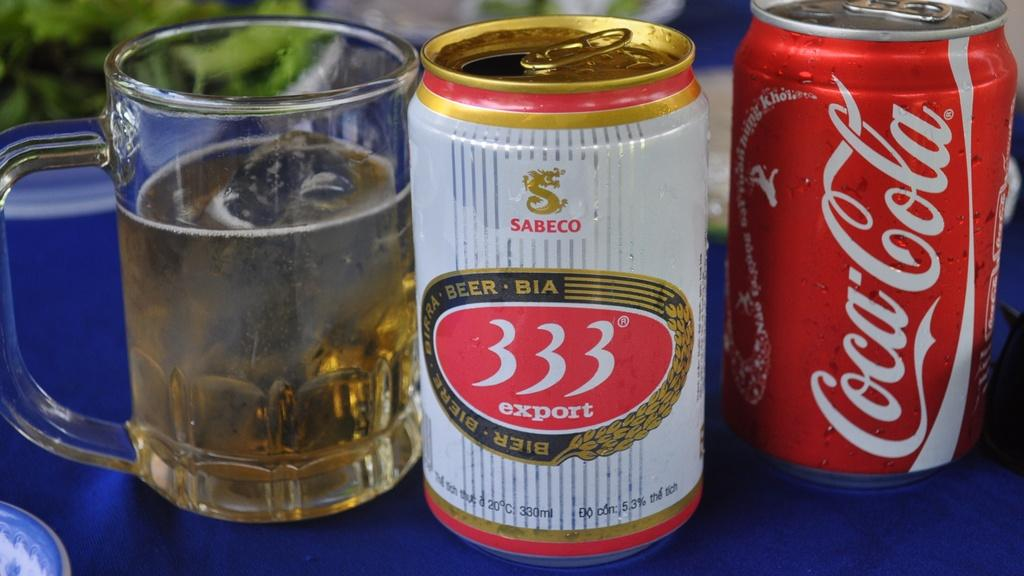Provide a one-sentence caption for the provided image. the numbers 333 are on the can of soda. 